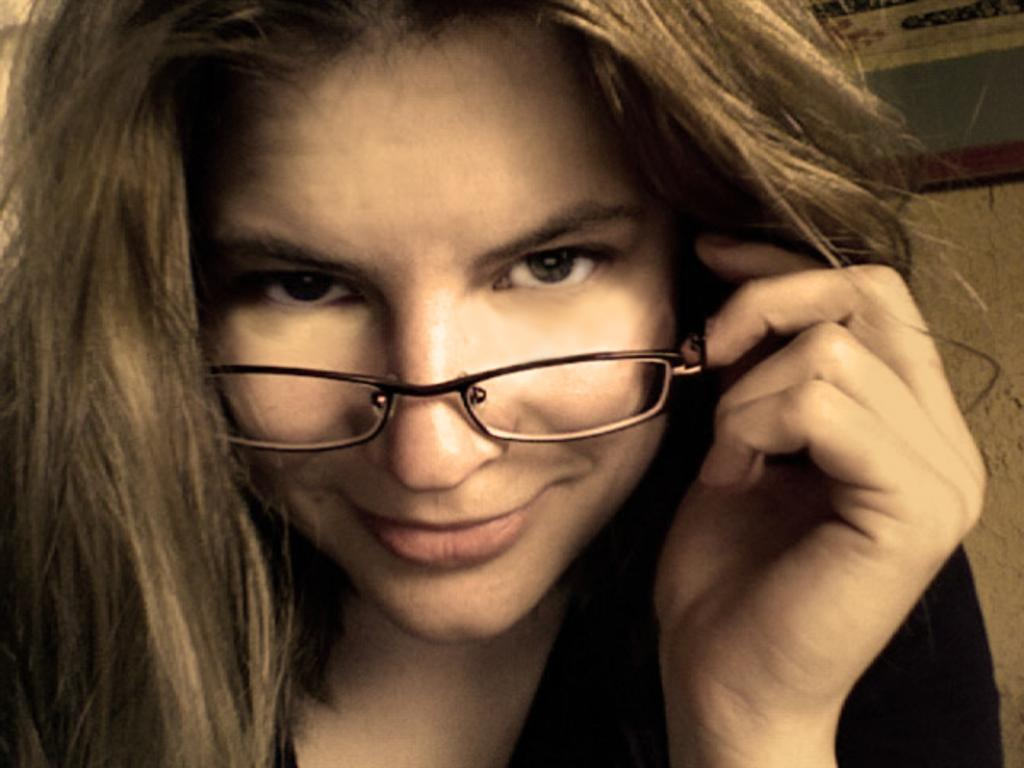Who is present in the image? There is a woman in the image. What is the woman wearing on her face? The woman is wearing spectacles. What can be seen in the background of the image? There is a wall in the background of the image. What type of nerve is being protested in the image? There is no protest or nerve present in the image; it features a woman wearing spectacles with a wall in the background. 